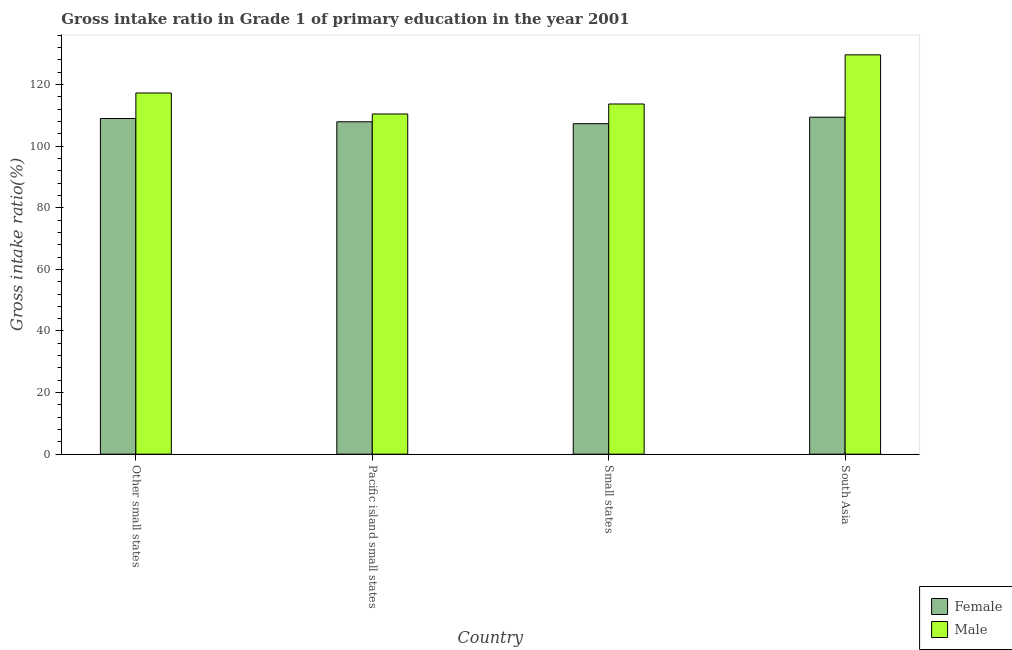How many different coloured bars are there?
Give a very brief answer. 2. How many groups of bars are there?
Provide a succinct answer. 4. How many bars are there on the 3rd tick from the left?
Offer a terse response. 2. How many bars are there on the 3rd tick from the right?
Offer a terse response. 2. What is the label of the 1st group of bars from the left?
Offer a terse response. Other small states. In how many cases, is the number of bars for a given country not equal to the number of legend labels?
Your answer should be very brief. 0. What is the gross intake ratio(male) in Pacific island small states?
Offer a terse response. 110.45. Across all countries, what is the maximum gross intake ratio(female)?
Make the answer very short. 109.41. Across all countries, what is the minimum gross intake ratio(female)?
Ensure brevity in your answer.  107.29. In which country was the gross intake ratio(female) minimum?
Make the answer very short. Small states. What is the total gross intake ratio(male) in the graph?
Offer a terse response. 471.05. What is the difference between the gross intake ratio(female) in Pacific island small states and that in South Asia?
Your response must be concise. -1.49. What is the difference between the gross intake ratio(female) in Pacific island small states and the gross intake ratio(male) in Other small states?
Give a very brief answer. -9.35. What is the average gross intake ratio(male) per country?
Give a very brief answer. 117.76. What is the difference between the gross intake ratio(female) and gross intake ratio(male) in Small states?
Ensure brevity in your answer.  -6.4. In how many countries, is the gross intake ratio(female) greater than 40 %?
Give a very brief answer. 4. What is the ratio of the gross intake ratio(female) in Pacific island small states to that in Small states?
Your answer should be very brief. 1.01. Is the gross intake ratio(female) in Other small states less than that in South Asia?
Offer a very short reply. Yes. What is the difference between the highest and the second highest gross intake ratio(female)?
Your answer should be compact. 0.43. What is the difference between the highest and the lowest gross intake ratio(male)?
Provide a succinct answer. 19.2. Are all the bars in the graph horizontal?
Give a very brief answer. No. How many countries are there in the graph?
Ensure brevity in your answer.  4. Are the values on the major ticks of Y-axis written in scientific E-notation?
Your answer should be very brief. No. Does the graph contain any zero values?
Offer a terse response. No. Does the graph contain grids?
Offer a very short reply. No. How many legend labels are there?
Ensure brevity in your answer.  2. What is the title of the graph?
Ensure brevity in your answer.  Gross intake ratio in Grade 1 of primary education in the year 2001. Does "Official aid received" appear as one of the legend labels in the graph?
Your answer should be very brief. No. What is the label or title of the X-axis?
Provide a succinct answer. Country. What is the label or title of the Y-axis?
Your response must be concise. Gross intake ratio(%). What is the Gross intake ratio(%) in Female in Other small states?
Ensure brevity in your answer.  108.98. What is the Gross intake ratio(%) in Male in Other small states?
Ensure brevity in your answer.  117.26. What is the Gross intake ratio(%) of Female in Pacific island small states?
Provide a succinct answer. 107.92. What is the Gross intake ratio(%) in Male in Pacific island small states?
Keep it short and to the point. 110.45. What is the Gross intake ratio(%) of Female in Small states?
Your answer should be compact. 107.29. What is the Gross intake ratio(%) of Male in Small states?
Ensure brevity in your answer.  113.69. What is the Gross intake ratio(%) in Female in South Asia?
Make the answer very short. 109.41. What is the Gross intake ratio(%) of Male in South Asia?
Provide a short and direct response. 129.65. Across all countries, what is the maximum Gross intake ratio(%) in Female?
Make the answer very short. 109.41. Across all countries, what is the maximum Gross intake ratio(%) of Male?
Offer a very short reply. 129.65. Across all countries, what is the minimum Gross intake ratio(%) of Female?
Your response must be concise. 107.29. Across all countries, what is the minimum Gross intake ratio(%) of Male?
Your answer should be very brief. 110.45. What is the total Gross intake ratio(%) of Female in the graph?
Give a very brief answer. 433.6. What is the total Gross intake ratio(%) of Male in the graph?
Your response must be concise. 471.05. What is the difference between the Gross intake ratio(%) in Female in Other small states and that in Pacific island small states?
Make the answer very short. 1.06. What is the difference between the Gross intake ratio(%) in Male in Other small states and that in Pacific island small states?
Your answer should be very brief. 6.82. What is the difference between the Gross intake ratio(%) of Female in Other small states and that in Small states?
Make the answer very short. 1.69. What is the difference between the Gross intake ratio(%) in Male in Other small states and that in Small states?
Provide a succinct answer. 3.57. What is the difference between the Gross intake ratio(%) of Female in Other small states and that in South Asia?
Provide a short and direct response. -0.43. What is the difference between the Gross intake ratio(%) of Male in Other small states and that in South Asia?
Keep it short and to the point. -12.39. What is the difference between the Gross intake ratio(%) of Female in Pacific island small states and that in Small states?
Keep it short and to the point. 0.62. What is the difference between the Gross intake ratio(%) in Male in Pacific island small states and that in Small states?
Make the answer very short. -3.25. What is the difference between the Gross intake ratio(%) in Female in Pacific island small states and that in South Asia?
Offer a terse response. -1.49. What is the difference between the Gross intake ratio(%) in Male in Pacific island small states and that in South Asia?
Your answer should be very brief. -19.2. What is the difference between the Gross intake ratio(%) of Female in Small states and that in South Asia?
Make the answer very short. -2.11. What is the difference between the Gross intake ratio(%) of Male in Small states and that in South Asia?
Keep it short and to the point. -15.96. What is the difference between the Gross intake ratio(%) in Female in Other small states and the Gross intake ratio(%) in Male in Pacific island small states?
Ensure brevity in your answer.  -1.46. What is the difference between the Gross intake ratio(%) of Female in Other small states and the Gross intake ratio(%) of Male in Small states?
Give a very brief answer. -4.71. What is the difference between the Gross intake ratio(%) of Female in Other small states and the Gross intake ratio(%) of Male in South Asia?
Ensure brevity in your answer.  -20.67. What is the difference between the Gross intake ratio(%) of Female in Pacific island small states and the Gross intake ratio(%) of Male in Small states?
Give a very brief answer. -5.78. What is the difference between the Gross intake ratio(%) of Female in Pacific island small states and the Gross intake ratio(%) of Male in South Asia?
Your response must be concise. -21.73. What is the difference between the Gross intake ratio(%) in Female in Small states and the Gross intake ratio(%) in Male in South Asia?
Give a very brief answer. -22.36. What is the average Gross intake ratio(%) in Female per country?
Offer a terse response. 108.4. What is the average Gross intake ratio(%) of Male per country?
Keep it short and to the point. 117.76. What is the difference between the Gross intake ratio(%) in Female and Gross intake ratio(%) in Male in Other small states?
Keep it short and to the point. -8.28. What is the difference between the Gross intake ratio(%) in Female and Gross intake ratio(%) in Male in Pacific island small states?
Your answer should be very brief. -2.53. What is the difference between the Gross intake ratio(%) in Female and Gross intake ratio(%) in Male in Small states?
Make the answer very short. -6.4. What is the difference between the Gross intake ratio(%) of Female and Gross intake ratio(%) of Male in South Asia?
Provide a succinct answer. -20.24. What is the ratio of the Gross intake ratio(%) in Female in Other small states to that in Pacific island small states?
Give a very brief answer. 1.01. What is the ratio of the Gross intake ratio(%) of Male in Other small states to that in Pacific island small states?
Make the answer very short. 1.06. What is the ratio of the Gross intake ratio(%) of Female in Other small states to that in Small states?
Ensure brevity in your answer.  1.02. What is the ratio of the Gross intake ratio(%) in Male in Other small states to that in Small states?
Provide a succinct answer. 1.03. What is the ratio of the Gross intake ratio(%) of Male in Other small states to that in South Asia?
Offer a very short reply. 0.9. What is the ratio of the Gross intake ratio(%) of Male in Pacific island small states to that in Small states?
Give a very brief answer. 0.97. What is the ratio of the Gross intake ratio(%) in Female in Pacific island small states to that in South Asia?
Keep it short and to the point. 0.99. What is the ratio of the Gross intake ratio(%) of Male in Pacific island small states to that in South Asia?
Provide a succinct answer. 0.85. What is the ratio of the Gross intake ratio(%) of Female in Small states to that in South Asia?
Offer a very short reply. 0.98. What is the ratio of the Gross intake ratio(%) in Male in Small states to that in South Asia?
Your response must be concise. 0.88. What is the difference between the highest and the second highest Gross intake ratio(%) in Female?
Keep it short and to the point. 0.43. What is the difference between the highest and the second highest Gross intake ratio(%) of Male?
Make the answer very short. 12.39. What is the difference between the highest and the lowest Gross intake ratio(%) of Female?
Make the answer very short. 2.11. What is the difference between the highest and the lowest Gross intake ratio(%) in Male?
Offer a terse response. 19.2. 